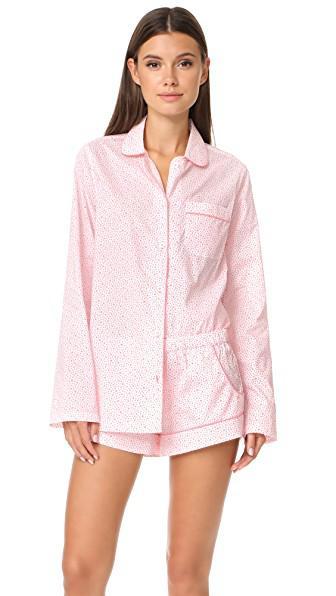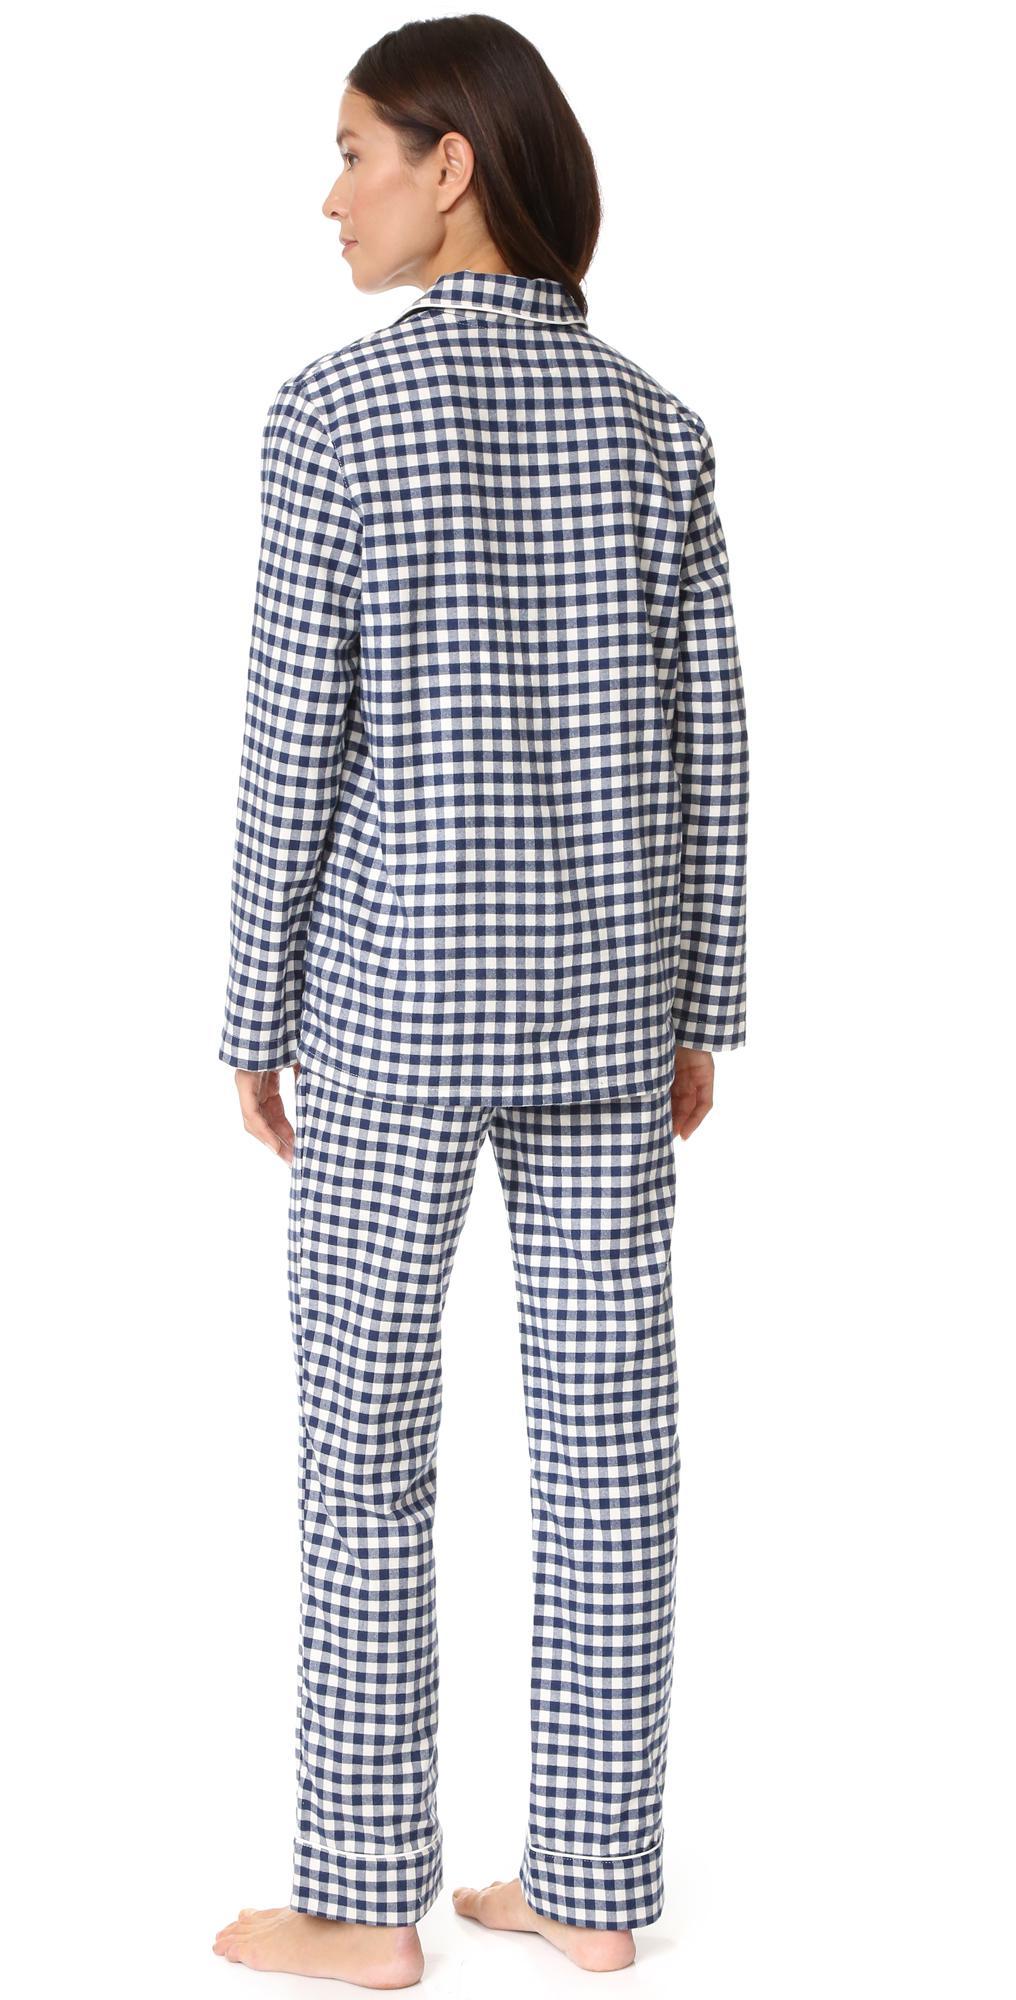The first image is the image on the left, the second image is the image on the right. Evaluate the accuracy of this statement regarding the images: "Two pajama models are facing front and shown full length, each striking a pose similar to the other person.". Is it true? Answer yes or no. No. The first image is the image on the left, the second image is the image on the right. Given the left and right images, does the statement "All models face forward and wear long pants, and at least one model wears dark pants with an all-over print." hold true? Answer yes or no. No. 